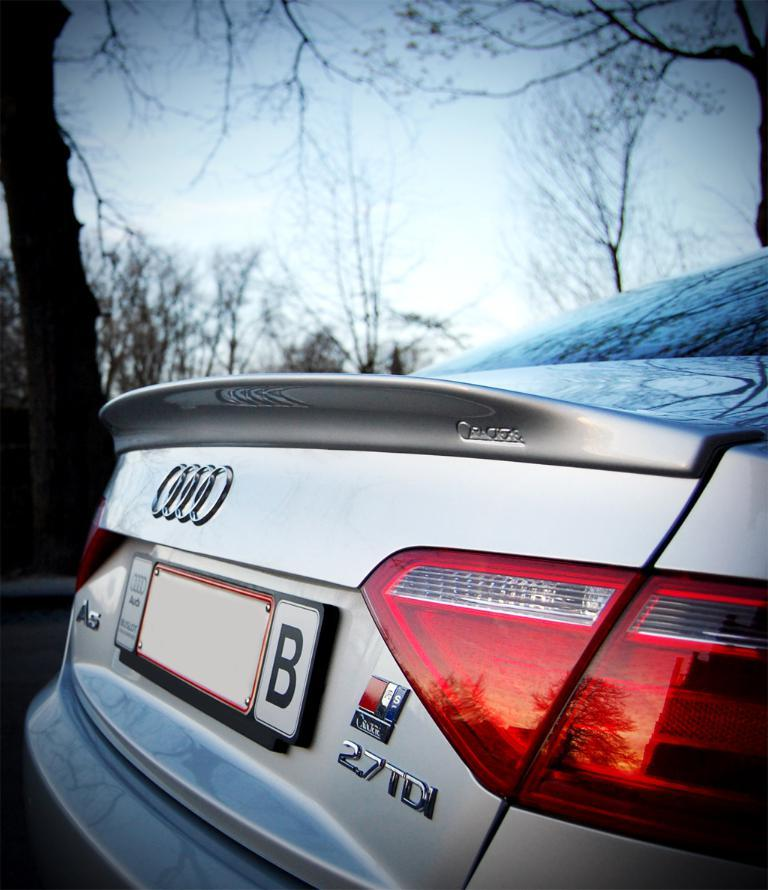<image>
Summarize the visual content of the image. The back of a silver Audi A5 sedan. 